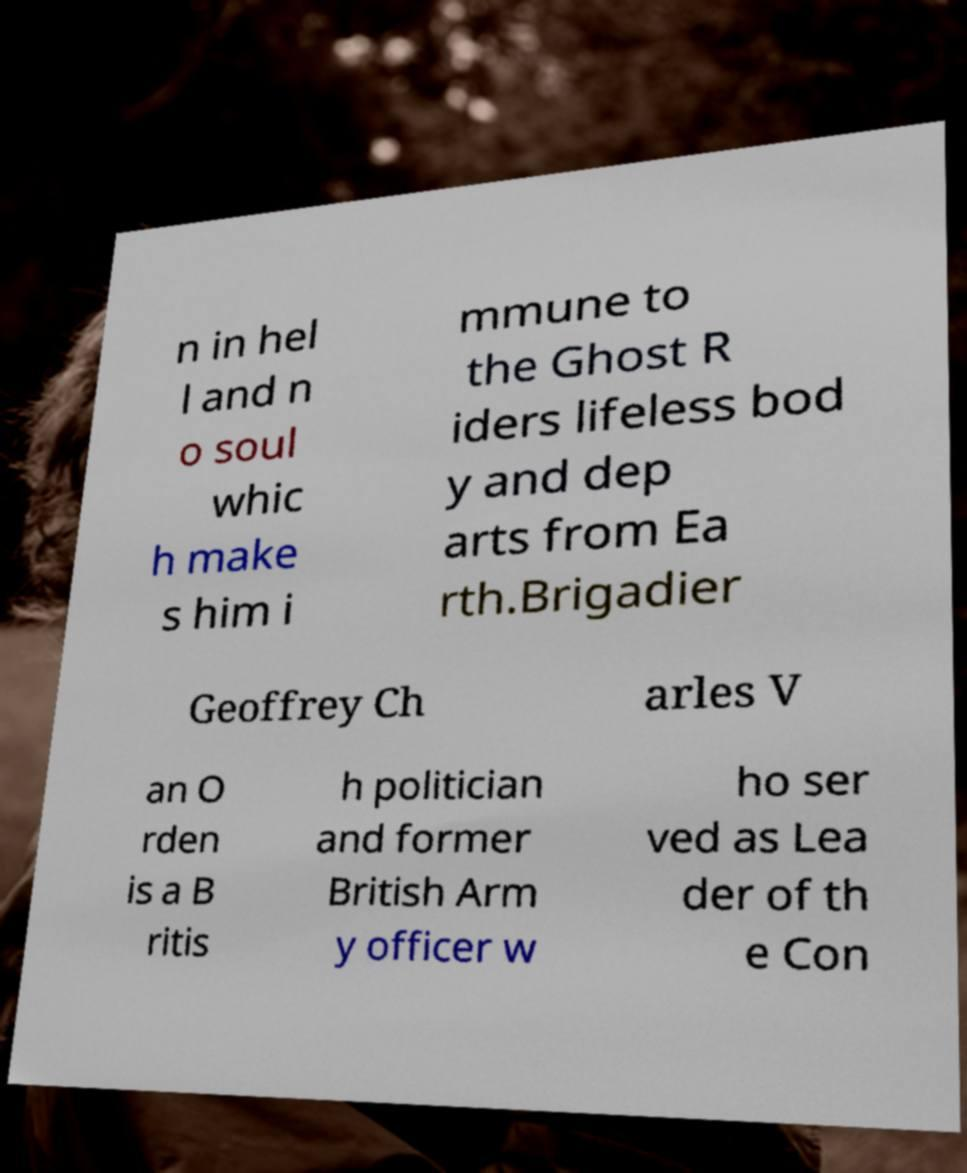I need the written content from this picture converted into text. Can you do that? n in hel l and n o soul whic h make s him i mmune to the Ghost R iders lifeless bod y and dep arts from Ea rth.Brigadier Geoffrey Ch arles V an O rden is a B ritis h politician and former British Arm y officer w ho ser ved as Lea der of th e Con 